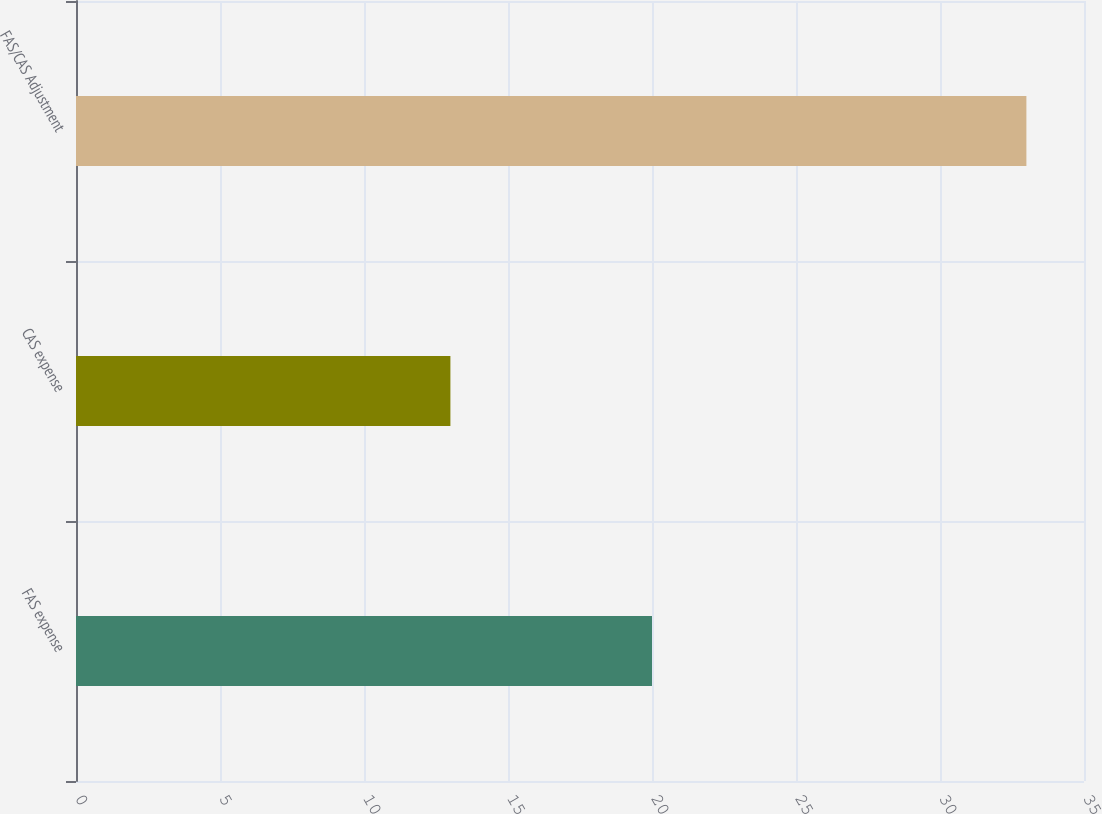<chart> <loc_0><loc_0><loc_500><loc_500><bar_chart><fcel>FAS expense<fcel>CAS expense<fcel>FAS/CAS Adjustment<nl><fcel>20<fcel>13<fcel>33<nl></chart> 